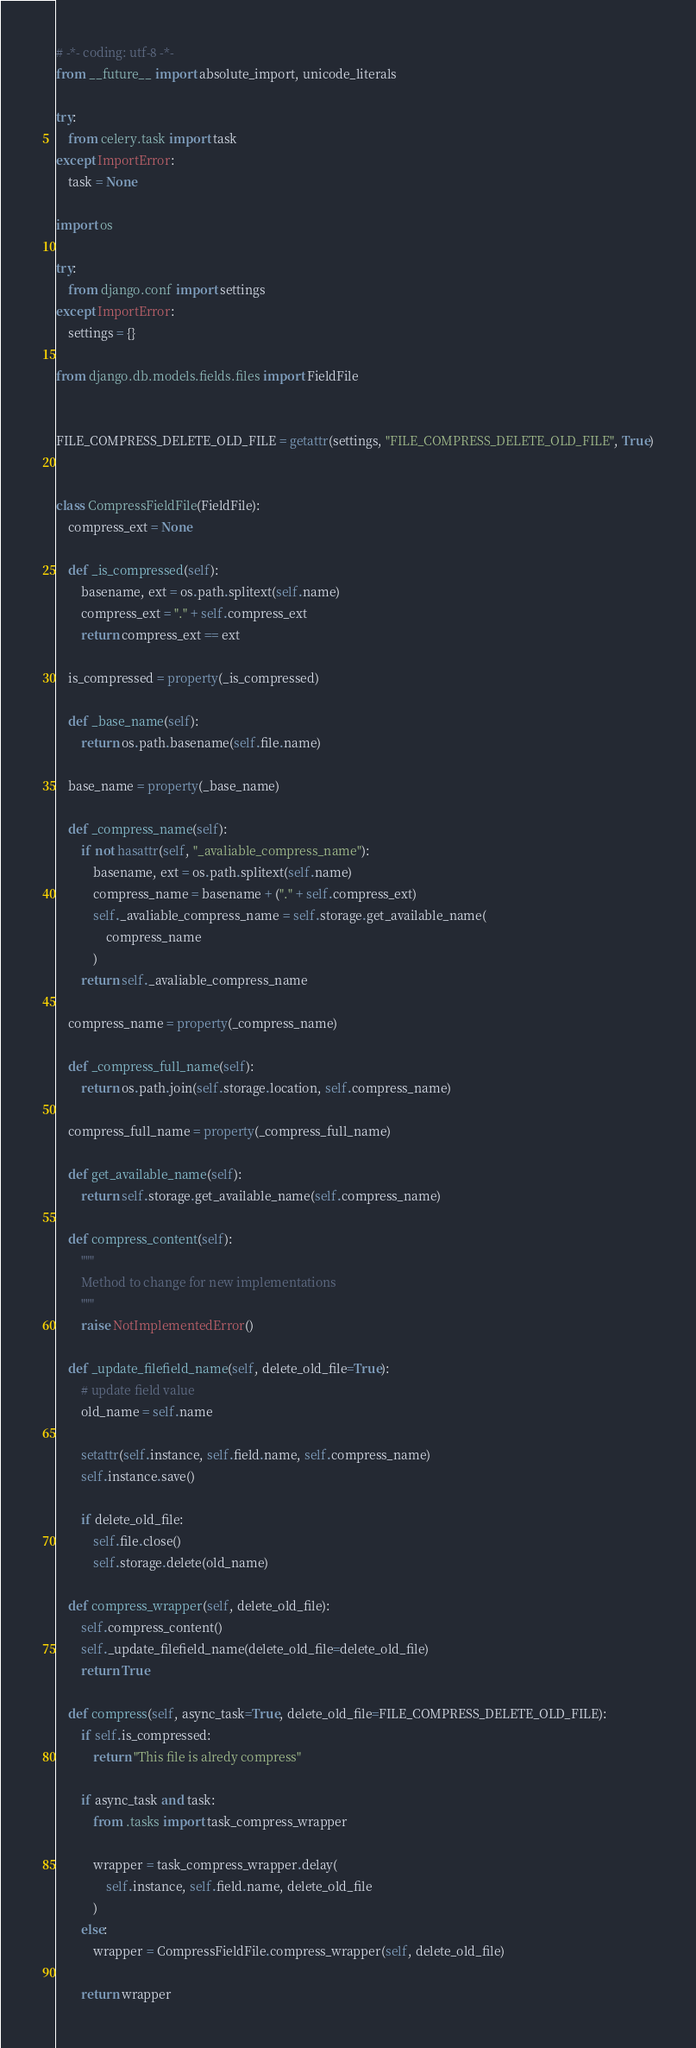<code> <loc_0><loc_0><loc_500><loc_500><_Python_># -*- coding: utf-8 -*-
from __future__ import absolute_import, unicode_literals

try:
    from celery.task import task
except ImportError:
    task = None

import os

try:
    from django.conf import settings
except ImportError:
    settings = {}

from django.db.models.fields.files import FieldFile


FILE_COMPRESS_DELETE_OLD_FILE = getattr(settings, "FILE_COMPRESS_DELETE_OLD_FILE", True)


class CompressFieldFile(FieldFile):
    compress_ext = None

    def _is_compressed(self):
        basename, ext = os.path.splitext(self.name)
        compress_ext = "." + self.compress_ext
        return compress_ext == ext

    is_compressed = property(_is_compressed)

    def _base_name(self):
        return os.path.basename(self.file.name)

    base_name = property(_base_name)

    def _compress_name(self):
        if not hasattr(self, "_avaliable_compress_name"):
            basename, ext = os.path.splitext(self.name)
            compress_name = basename + ("." + self.compress_ext)
            self._avaliable_compress_name = self.storage.get_available_name(
                compress_name
            )
        return self._avaliable_compress_name

    compress_name = property(_compress_name)

    def _compress_full_name(self):
        return os.path.join(self.storage.location, self.compress_name)

    compress_full_name = property(_compress_full_name)

    def get_available_name(self):
        return self.storage.get_available_name(self.compress_name)

    def compress_content(self):
        """
        Method to change for new implementations
        """
        raise NotImplementedError()

    def _update_filefield_name(self, delete_old_file=True):
        # update field value
        old_name = self.name

        setattr(self.instance, self.field.name, self.compress_name)
        self.instance.save()

        if delete_old_file:
            self.file.close()
            self.storage.delete(old_name)

    def compress_wrapper(self, delete_old_file):
        self.compress_content()
        self._update_filefield_name(delete_old_file=delete_old_file)
        return True

    def compress(self, async_task=True, delete_old_file=FILE_COMPRESS_DELETE_OLD_FILE):
        if self.is_compressed:
            return "This file is alredy compress"

        if async_task and task:
            from .tasks import task_compress_wrapper

            wrapper = task_compress_wrapper.delay(
                self.instance, self.field.name, delete_old_file
            )
        else:
            wrapper = CompressFieldFile.compress_wrapper(self, delete_old_file)

        return wrapper
</code> 